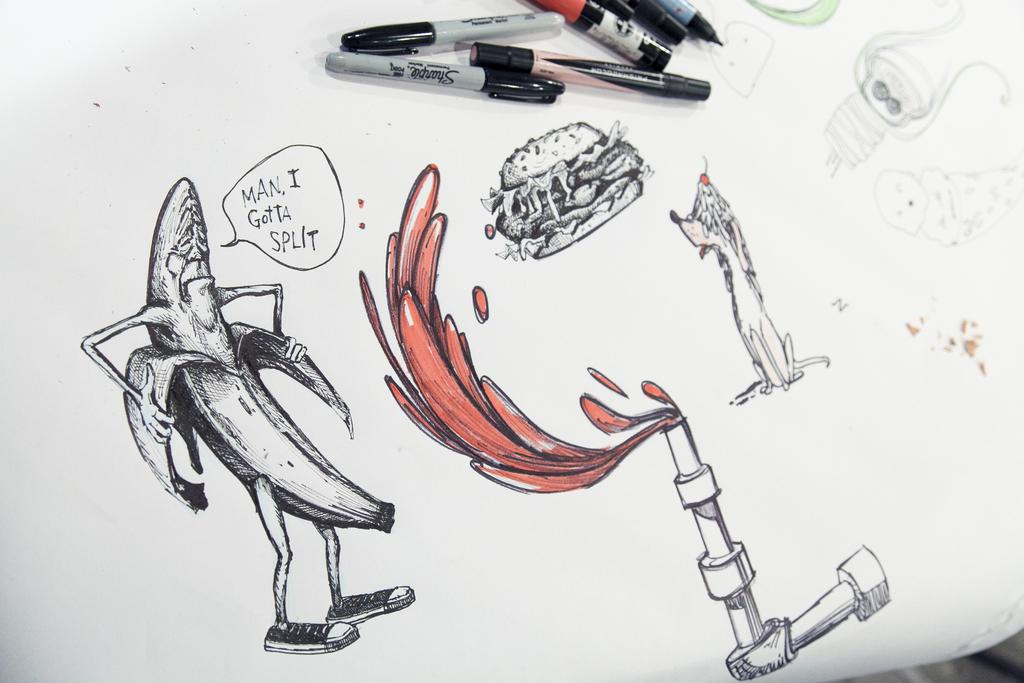What is the main object in the image? There is a white paper in the image. What can be seen on the white paper? There are drawings and writing on the white paper. What tools are used to create the drawings and writing? There are visible in the image. Reasoning: Let's think step by following the given format. We start by identifying the main object in the image, which is the white paper. Then, we describe the content on the paper, mentioning that there are drawings and writing. Finally, we identify the tools used to create the drawings and writing, which are markers. Each question is designed to elicit a specific detail about the image that is known from the provided facts. Absurd Question/Answer: How many rabbits are hopping around in the image? There are no rabbits present in the image. What is the name of the person who drew the drawings on the white paper? The image does not provide any information about the name of the person who drew the drawings. What type of bath is visible in the image? There is no bath present in the image. How many rabbits are interacting with the drawings on the white paper? There are no rabbits present in the image. 